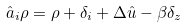<formula> <loc_0><loc_0><loc_500><loc_500>\hat { a } _ { i } \rho & = \rho + \delta _ { i } + \Delta \hat { u } - \beta \delta _ { z }</formula> 